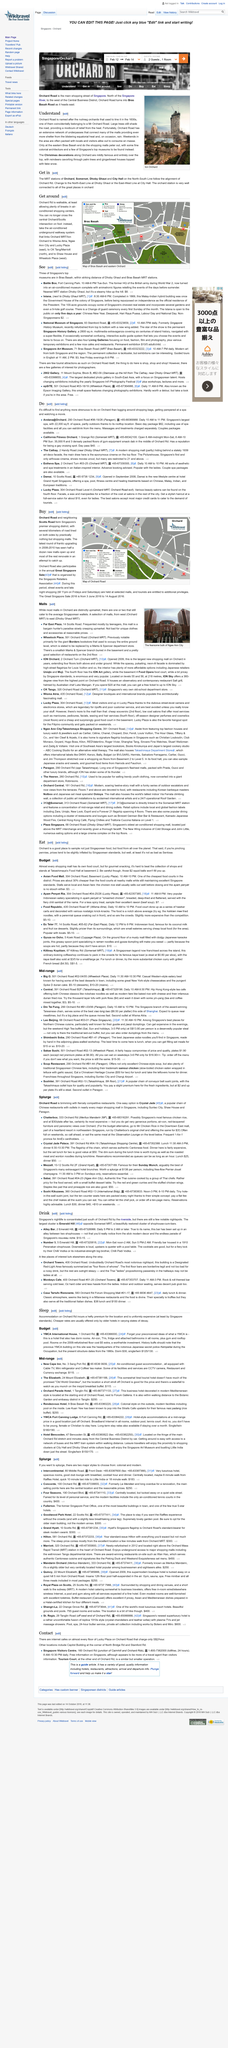Identify some key points in this picture. It is now prohibited for individuals to cross the Scotts/Orchard intersection on foot. There are several attractions to see and do in the Bras Basah area, including 2902 Gallery, The Cathay, Battle Box, National Museum, and Singapore Art Museum. The caption used for this photo is 'The fearsome bulk of Ngee Ann City towering over the city skyline.' What is the address of Far East Plaza? It is located at 14 Scotts Road. The address for Wheelock Place is 501 Orchard Road, which can be found at Orchard MRT Station. 